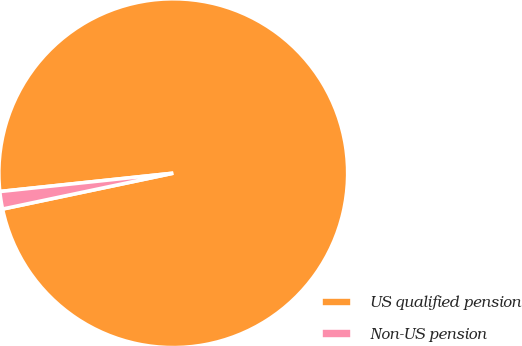Convert chart. <chart><loc_0><loc_0><loc_500><loc_500><pie_chart><fcel>US qualified pension<fcel>Non-US pension<nl><fcel>98.38%<fcel>1.62%<nl></chart> 